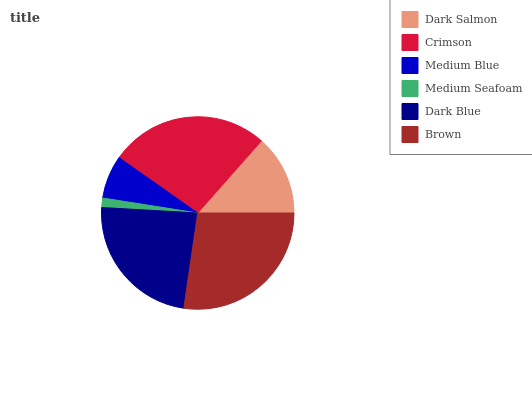Is Medium Seafoam the minimum?
Answer yes or no. Yes. Is Brown the maximum?
Answer yes or no. Yes. Is Crimson the minimum?
Answer yes or no. No. Is Crimson the maximum?
Answer yes or no. No. Is Crimson greater than Dark Salmon?
Answer yes or no. Yes. Is Dark Salmon less than Crimson?
Answer yes or no. Yes. Is Dark Salmon greater than Crimson?
Answer yes or no. No. Is Crimson less than Dark Salmon?
Answer yes or no. No. Is Dark Blue the high median?
Answer yes or no. Yes. Is Dark Salmon the low median?
Answer yes or no. Yes. Is Crimson the high median?
Answer yes or no. No. Is Dark Blue the low median?
Answer yes or no. No. 